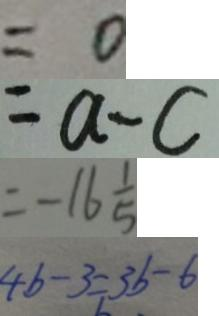<formula> <loc_0><loc_0><loc_500><loc_500>= 0 
 = a - c 
 = - 1 6 \frac { 1 } { 5 } 
 4 b - 3 = 3 b - b</formula> 